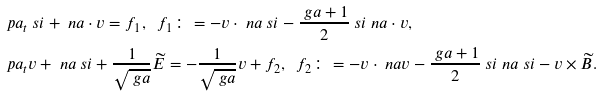<formula> <loc_0><loc_0><loc_500><loc_500>& \ p a _ { t } \ s i + \ n a \cdot v = f _ { 1 } , \ \ f _ { 1 } \colon = - v \cdot \ n a \ s i - \frac { \ g a + 1 } { 2 } \ s i \ n a \cdot v , \\ & \ p a _ { t } v + \ n a \ s i + \frac { 1 } { \sqrt { \ g a } } \widetilde { E } = - \frac { 1 } { \sqrt { \ g a } } v + f _ { 2 } , \ \ f _ { 2 } \colon = - v \cdot \ n a v - \frac { \ g a + 1 } { 2 } \ s i \ n a \ s i - v \times \widetilde { B } .</formula> 